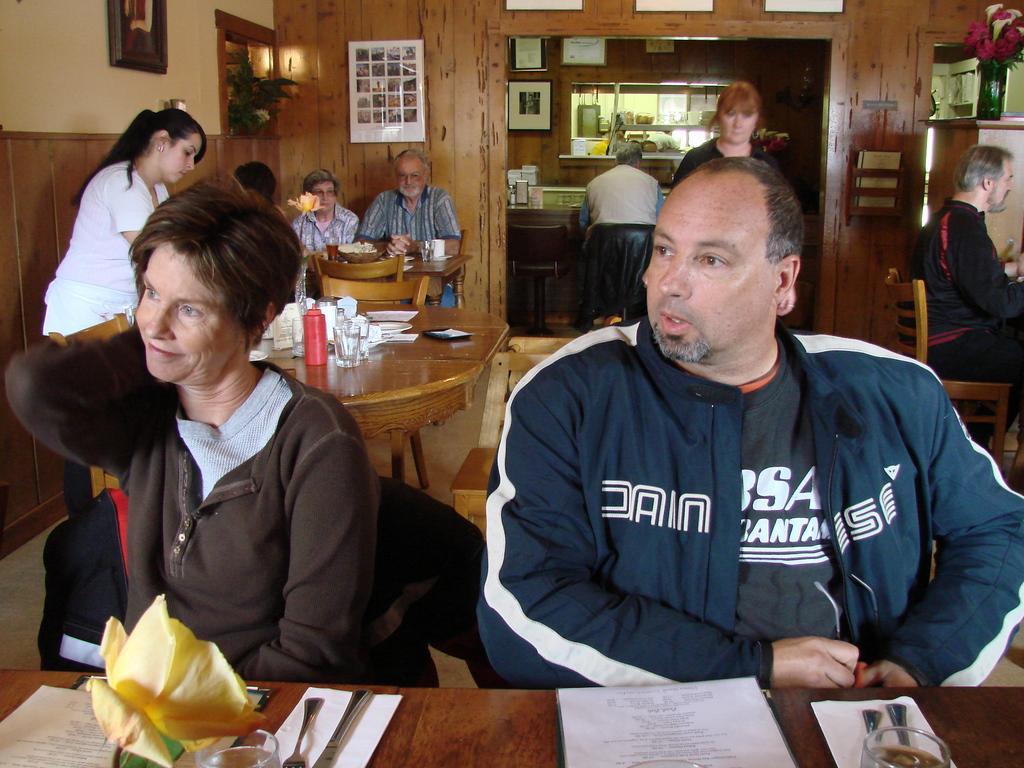How would you summarize this image in a sentence or two? In the picture we can find a man and a woman sitting on the chairs near the table. On the table we can find a flower, a spoon, a glass and some papers. In the background we can find two people are standing, two people are sitting, and on the table we can find some glasses and papers, plates and we can also find a wall with photos. 